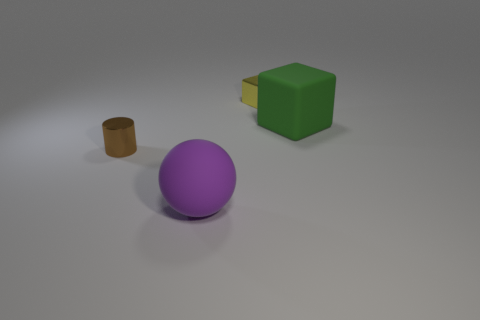There is a thing that is behind the small brown object and to the left of the green rubber object; what is its material?
Provide a succinct answer. Metal. There is a big thing to the right of the small yellow shiny cube; what is its material?
Provide a short and direct response. Rubber. There is a large object that is the same material as the green block; what color is it?
Offer a very short reply. Purple. There is a green thing; is its shape the same as the metallic object in front of the tiny metal cube?
Your answer should be compact. No. There is a big purple rubber object; are there any small brown cylinders on the right side of it?
Provide a succinct answer. No. There is a brown cylinder; is its size the same as the cube in front of the yellow block?
Provide a short and direct response. No. Is there a sphere that has the same color as the large matte block?
Offer a very short reply. No. Is there another tiny yellow metal object that has the same shape as the yellow metallic thing?
Ensure brevity in your answer.  No. What shape is the object that is both behind the matte ball and in front of the large green matte object?
Make the answer very short. Cylinder. How many other small yellow blocks have the same material as the small yellow block?
Ensure brevity in your answer.  0. 